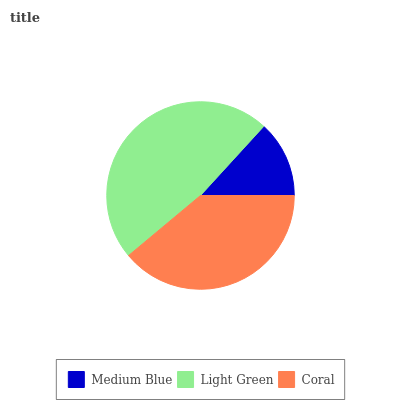Is Medium Blue the minimum?
Answer yes or no. Yes. Is Light Green the maximum?
Answer yes or no. Yes. Is Coral the minimum?
Answer yes or no. No. Is Coral the maximum?
Answer yes or no. No. Is Light Green greater than Coral?
Answer yes or no. Yes. Is Coral less than Light Green?
Answer yes or no. Yes. Is Coral greater than Light Green?
Answer yes or no. No. Is Light Green less than Coral?
Answer yes or no. No. Is Coral the high median?
Answer yes or no. Yes. Is Coral the low median?
Answer yes or no. Yes. Is Medium Blue the high median?
Answer yes or no. No. Is Medium Blue the low median?
Answer yes or no. No. 